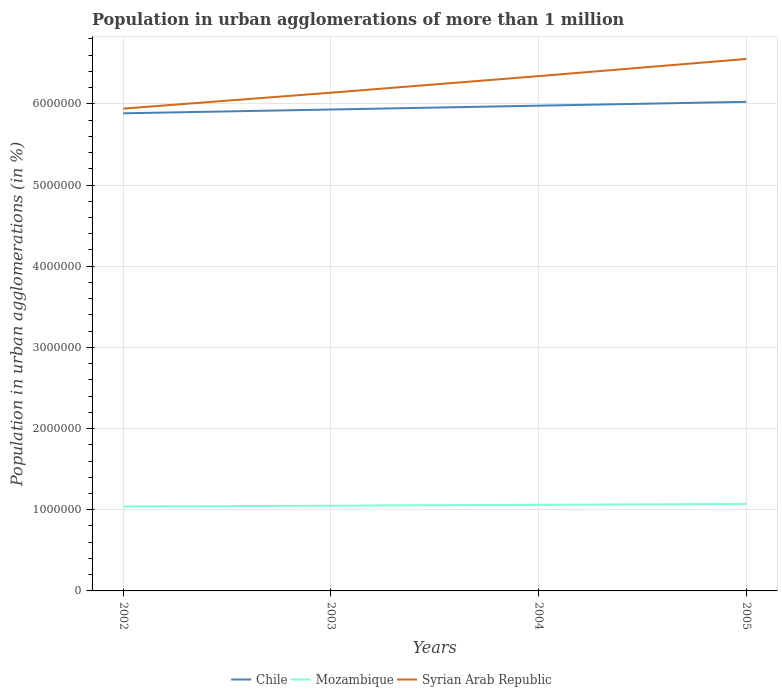Does the line corresponding to Syrian Arab Republic intersect with the line corresponding to Chile?
Your response must be concise. No. Is the number of lines equal to the number of legend labels?
Keep it short and to the point. Yes. Across all years, what is the maximum population in urban agglomerations in Mozambique?
Provide a short and direct response. 1.04e+06. What is the total population in urban agglomerations in Mozambique in the graph?
Offer a terse response. -2.12e+04. What is the difference between the highest and the second highest population in urban agglomerations in Syrian Arab Republic?
Offer a terse response. 6.12e+05. Is the population in urban agglomerations in Mozambique strictly greater than the population in urban agglomerations in Syrian Arab Republic over the years?
Offer a very short reply. Yes. How many lines are there?
Your answer should be compact. 3. Where does the legend appear in the graph?
Offer a very short reply. Bottom center. What is the title of the graph?
Provide a short and direct response. Population in urban agglomerations of more than 1 million. What is the label or title of the X-axis?
Ensure brevity in your answer.  Years. What is the label or title of the Y-axis?
Ensure brevity in your answer.  Population in urban agglomerations (in %). What is the Population in urban agglomerations (in %) of Chile in 2002?
Provide a short and direct response. 5.88e+06. What is the Population in urban agglomerations (in %) in Mozambique in 2002?
Keep it short and to the point. 1.04e+06. What is the Population in urban agglomerations (in %) of Syrian Arab Republic in 2002?
Give a very brief answer. 5.94e+06. What is the Population in urban agglomerations (in %) of Chile in 2003?
Ensure brevity in your answer.  5.93e+06. What is the Population in urban agglomerations (in %) in Mozambique in 2003?
Ensure brevity in your answer.  1.05e+06. What is the Population in urban agglomerations (in %) in Syrian Arab Republic in 2003?
Provide a succinct answer. 6.14e+06. What is the Population in urban agglomerations (in %) in Chile in 2004?
Your response must be concise. 5.98e+06. What is the Population in urban agglomerations (in %) in Mozambique in 2004?
Provide a succinct answer. 1.06e+06. What is the Population in urban agglomerations (in %) in Syrian Arab Republic in 2004?
Offer a very short reply. 6.34e+06. What is the Population in urban agglomerations (in %) of Chile in 2005?
Your response must be concise. 6.03e+06. What is the Population in urban agglomerations (in %) of Mozambique in 2005?
Your answer should be compact. 1.07e+06. What is the Population in urban agglomerations (in %) in Syrian Arab Republic in 2005?
Offer a very short reply. 6.55e+06. Across all years, what is the maximum Population in urban agglomerations (in %) in Chile?
Offer a very short reply. 6.03e+06. Across all years, what is the maximum Population in urban agglomerations (in %) in Mozambique?
Offer a terse response. 1.07e+06. Across all years, what is the maximum Population in urban agglomerations (in %) in Syrian Arab Republic?
Keep it short and to the point. 6.55e+06. Across all years, what is the minimum Population in urban agglomerations (in %) of Chile?
Offer a very short reply. 5.88e+06. Across all years, what is the minimum Population in urban agglomerations (in %) in Mozambique?
Your answer should be compact. 1.04e+06. Across all years, what is the minimum Population in urban agglomerations (in %) of Syrian Arab Republic?
Offer a terse response. 5.94e+06. What is the total Population in urban agglomerations (in %) in Chile in the graph?
Your answer should be very brief. 2.38e+07. What is the total Population in urban agglomerations (in %) in Mozambique in the graph?
Provide a succinct answer. 4.22e+06. What is the total Population in urban agglomerations (in %) in Syrian Arab Republic in the graph?
Give a very brief answer. 2.50e+07. What is the difference between the Population in urban agglomerations (in %) of Chile in 2002 and that in 2003?
Keep it short and to the point. -4.69e+04. What is the difference between the Population in urban agglomerations (in %) of Mozambique in 2002 and that in 2003?
Keep it short and to the point. -1.06e+04. What is the difference between the Population in urban agglomerations (in %) in Syrian Arab Republic in 2002 and that in 2003?
Make the answer very short. -1.96e+05. What is the difference between the Population in urban agglomerations (in %) in Chile in 2002 and that in 2004?
Your answer should be very brief. -9.42e+04. What is the difference between the Population in urban agglomerations (in %) of Mozambique in 2002 and that in 2004?
Provide a short and direct response. -2.12e+04. What is the difference between the Population in urban agglomerations (in %) of Syrian Arab Republic in 2002 and that in 2004?
Offer a very short reply. -4.00e+05. What is the difference between the Population in urban agglomerations (in %) in Chile in 2002 and that in 2005?
Give a very brief answer. -1.42e+05. What is the difference between the Population in urban agglomerations (in %) of Mozambique in 2002 and that in 2005?
Your response must be concise. -3.20e+04. What is the difference between the Population in urban agglomerations (in %) in Syrian Arab Republic in 2002 and that in 2005?
Offer a terse response. -6.12e+05. What is the difference between the Population in urban agglomerations (in %) in Chile in 2003 and that in 2004?
Make the answer very short. -4.73e+04. What is the difference between the Population in urban agglomerations (in %) in Mozambique in 2003 and that in 2004?
Ensure brevity in your answer.  -1.07e+04. What is the difference between the Population in urban agglomerations (in %) of Syrian Arab Republic in 2003 and that in 2004?
Keep it short and to the point. -2.04e+05. What is the difference between the Population in urban agglomerations (in %) in Chile in 2003 and that in 2005?
Your answer should be very brief. -9.49e+04. What is the difference between the Population in urban agglomerations (in %) in Mozambique in 2003 and that in 2005?
Offer a terse response. -2.14e+04. What is the difference between the Population in urban agglomerations (in %) of Syrian Arab Republic in 2003 and that in 2005?
Your answer should be compact. -4.16e+05. What is the difference between the Population in urban agglomerations (in %) of Chile in 2004 and that in 2005?
Offer a very short reply. -4.76e+04. What is the difference between the Population in urban agglomerations (in %) in Mozambique in 2004 and that in 2005?
Ensure brevity in your answer.  -1.08e+04. What is the difference between the Population in urban agglomerations (in %) of Syrian Arab Republic in 2004 and that in 2005?
Your response must be concise. -2.12e+05. What is the difference between the Population in urban agglomerations (in %) of Chile in 2002 and the Population in urban agglomerations (in %) of Mozambique in 2003?
Ensure brevity in your answer.  4.83e+06. What is the difference between the Population in urban agglomerations (in %) of Chile in 2002 and the Population in urban agglomerations (in %) of Syrian Arab Republic in 2003?
Make the answer very short. -2.54e+05. What is the difference between the Population in urban agglomerations (in %) in Mozambique in 2002 and the Population in urban agglomerations (in %) in Syrian Arab Republic in 2003?
Your answer should be compact. -5.10e+06. What is the difference between the Population in urban agglomerations (in %) of Chile in 2002 and the Population in urban agglomerations (in %) of Mozambique in 2004?
Make the answer very short. 4.82e+06. What is the difference between the Population in urban agglomerations (in %) of Chile in 2002 and the Population in urban agglomerations (in %) of Syrian Arab Republic in 2004?
Your answer should be very brief. -4.58e+05. What is the difference between the Population in urban agglomerations (in %) of Mozambique in 2002 and the Population in urban agglomerations (in %) of Syrian Arab Republic in 2004?
Provide a short and direct response. -5.30e+06. What is the difference between the Population in urban agglomerations (in %) in Chile in 2002 and the Population in urban agglomerations (in %) in Mozambique in 2005?
Offer a very short reply. 4.81e+06. What is the difference between the Population in urban agglomerations (in %) of Chile in 2002 and the Population in urban agglomerations (in %) of Syrian Arab Republic in 2005?
Your answer should be compact. -6.70e+05. What is the difference between the Population in urban agglomerations (in %) of Mozambique in 2002 and the Population in urban agglomerations (in %) of Syrian Arab Republic in 2005?
Offer a very short reply. -5.51e+06. What is the difference between the Population in urban agglomerations (in %) of Chile in 2003 and the Population in urban agglomerations (in %) of Mozambique in 2004?
Your answer should be very brief. 4.87e+06. What is the difference between the Population in urban agglomerations (in %) of Chile in 2003 and the Population in urban agglomerations (in %) of Syrian Arab Republic in 2004?
Offer a terse response. -4.11e+05. What is the difference between the Population in urban agglomerations (in %) in Mozambique in 2003 and the Population in urban agglomerations (in %) in Syrian Arab Republic in 2004?
Your response must be concise. -5.29e+06. What is the difference between the Population in urban agglomerations (in %) of Chile in 2003 and the Population in urban agglomerations (in %) of Mozambique in 2005?
Offer a terse response. 4.86e+06. What is the difference between the Population in urban agglomerations (in %) of Chile in 2003 and the Population in urban agglomerations (in %) of Syrian Arab Republic in 2005?
Your response must be concise. -6.23e+05. What is the difference between the Population in urban agglomerations (in %) in Mozambique in 2003 and the Population in urban agglomerations (in %) in Syrian Arab Republic in 2005?
Your answer should be compact. -5.50e+06. What is the difference between the Population in urban agglomerations (in %) in Chile in 2004 and the Population in urban agglomerations (in %) in Mozambique in 2005?
Give a very brief answer. 4.91e+06. What is the difference between the Population in urban agglomerations (in %) in Chile in 2004 and the Population in urban agglomerations (in %) in Syrian Arab Republic in 2005?
Offer a very short reply. -5.75e+05. What is the difference between the Population in urban agglomerations (in %) in Mozambique in 2004 and the Population in urban agglomerations (in %) in Syrian Arab Republic in 2005?
Provide a succinct answer. -5.49e+06. What is the average Population in urban agglomerations (in %) in Chile per year?
Offer a very short reply. 5.95e+06. What is the average Population in urban agglomerations (in %) of Mozambique per year?
Keep it short and to the point. 1.06e+06. What is the average Population in urban agglomerations (in %) in Syrian Arab Republic per year?
Ensure brevity in your answer.  6.24e+06. In the year 2002, what is the difference between the Population in urban agglomerations (in %) in Chile and Population in urban agglomerations (in %) in Mozambique?
Offer a very short reply. 4.84e+06. In the year 2002, what is the difference between the Population in urban agglomerations (in %) of Chile and Population in urban agglomerations (in %) of Syrian Arab Republic?
Provide a succinct answer. -5.79e+04. In the year 2002, what is the difference between the Population in urban agglomerations (in %) of Mozambique and Population in urban agglomerations (in %) of Syrian Arab Republic?
Your response must be concise. -4.90e+06. In the year 2003, what is the difference between the Population in urban agglomerations (in %) of Chile and Population in urban agglomerations (in %) of Mozambique?
Provide a short and direct response. 4.88e+06. In the year 2003, what is the difference between the Population in urban agglomerations (in %) in Chile and Population in urban agglomerations (in %) in Syrian Arab Republic?
Your answer should be compact. -2.07e+05. In the year 2003, what is the difference between the Population in urban agglomerations (in %) of Mozambique and Population in urban agglomerations (in %) of Syrian Arab Republic?
Give a very brief answer. -5.09e+06. In the year 2004, what is the difference between the Population in urban agglomerations (in %) of Chile and Population in urban agglomerations (in %) of Mozambique?
Offer a terse response. 4.92e+06. In the year 2004, what is the difference between the Population in urban agglomerations (in %) in Chile and Population in urban agglomerations (in %) in Syrian Arab Republic?
Your response must be concise. -3.64e+05. In the year 2004, what is the difference between the Population in urban agglomerations (in %) in Mozambique and Population in urban agglomerations (in %) in Syrian Arab Republic?
Your answer should be very brief. -5.28e+06. In the year 2005, what is the difference between the Population in urban agglomerations (in %) of Chile and Population in urban agglomerations (in %) of Mozambique?
Your answer should be compact. 4.95e+06. In the year 2005, what is the difference between the Population in urban agglomerations (in %) in Chile and Population in urban agglomerations (in %) in Syrian Arab Republic?
Offer a terse response. -5.28e+05. In the year 2005, what is the difference between the Population in urban agglomerations (in %) in Mozambique and Population in urban agglomerations (in %) in Syrian Arab Republic?
Keep it short and to the point. -5.48e+06. What is the ratio of the Population in urban agglomerations (in %) of Mozambique in 2002 to that in 2003?
Offer a terse response. 0.99. What is the ratio of the Population in urban agglomerations (in %) of Syrian Arab Republic in 2002 to that in 2003?
Make the answer very short. 0.97. What is the ratio of the Population in urban agglomerations (in %) of Chile in 2002 to that in 2004?
Provide a succinct answer. 0.98. What is the ratio of the Population in urban agglomerations (in %) of Syrian Arab Republic in 2002 to that in 2004?
Provide a short and direct response. 0.94. What is the ratio of the Population in urban agglomerations (in %) of Chile in 2002 to that in 2005?
Ensure brevity in your answer.  0.98. What is the ratio of the Population in urban agglomerations (in %) in Mozambique in 2002 to that in 2005?
Give a very brief answer. 0.97. What is the ratio of the Population in urban agglomerations (in %) of Syrian Arab Republic in 2002 to that in 2005?
Provide a short and direct response. 0.91. What is the ratio of the Population in urban agglomerations (in %) in Mozambique in 2003 to that in 2004?
Your answer should be compact. 0.99. What is the ratio of the Population in urban agglomerations (in %) in Syrian Arab Republic in 2003 to that in 2004?
Provide a succinct answer. 0.97. What is the ratio of the Population in urban agglomerations (in %) of Chile in 2003 to that in 2005?
Your answer should be compact. 0.98. What is the ratio of the Population in urban agglomerations (in %) in Syrian Arab Republic in 2003 to that in 2005?
Ensure brevity in your answer.  0.94. What is the ratio of the Population in urban agglomerations (in %) in Chile in 2004 to that in 2005?
Offer a terse response. 0.99. What is the ratio of the Population in urban agglomerations (in %) of Mozambique in 2004 to that in 2005?
Make the answer very short. 0.99. What is the difference between the highest and the second highest Population in urban agglomerations (in %) of Chile?
Provide a short and direct response. 4.76e+04. What is the difference between the highest and the second highest Population in urban agglomerations (in %) of Mozambique?
Make the answer very short. 1.08e+04. What is the difference between the highest and the second highest Population in urban agglomerations (in %) in Syrian Arab Republic?
Your response must be concise. 2.12e+05. What is the difference between the highest and the lowest Population in urban agglomerations (in %) in Chile?
Your response must be concise. 1.42e+05. What is the difference between the highest and the lowest Population in urban agglomerations (in %) of Mozambique?
Offer a very short reply. 3.20e+04. What is the difference between the highest and the lowest Population in urban agglomerations (in %) in Syrian Arab Republic?
Provide a succinct answer. 6.12e+05. 